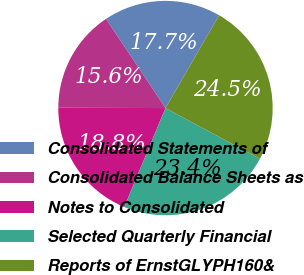Convert chart. <chart><loc_0><loc_0><loc_500><loc_500><pie_chart><fcel>Consolidated Statements of<fcel>Consolidated Balance Sheets as<fcel>Notes to Consolidated<fcel>Selected Quarterly Financial<fcel>Reports of ErnstGLYPH160&<nl><fcel>17.71%<fcel>15.58%<fcel>18.78%<fcel>23.43%<fcel>24.5%<nl></chart> 